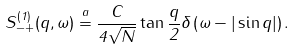<formula> <loc_0><loc_0><loc_500><loc_500>S _ { - + } ^ { ( 1 ) } ( q , \omega ) \stackrel { a } { = } \frac { C } { 4 \sqrt { N } } \tan \frac { q } { 2 } \delta \left ( \omega - | \sin q | \right ) .</formula> 